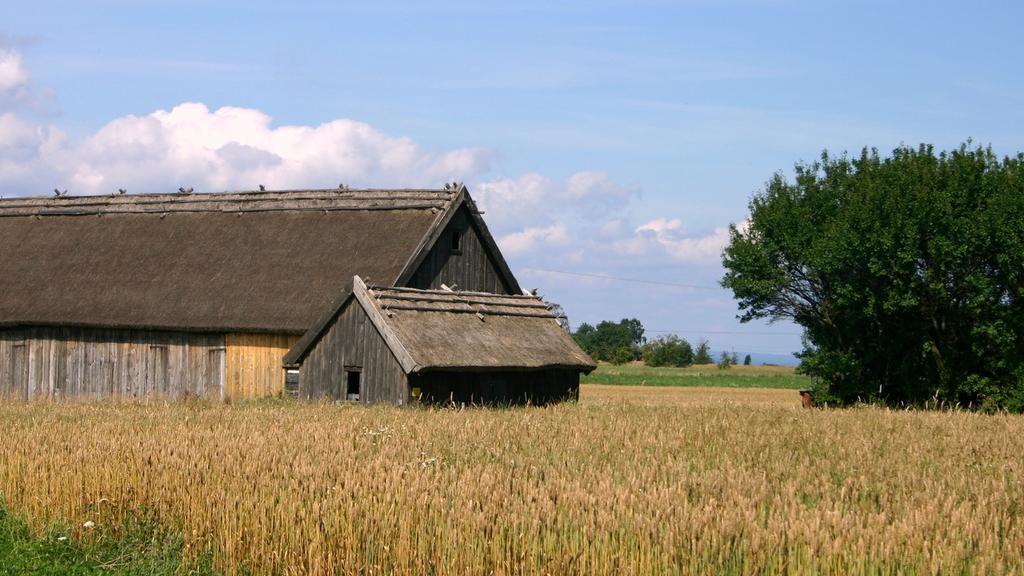Can you describe this image briefly? In the center of the image there is a house. At the bottom of the image there are crops. At the right side of the image there is a tree. At the top of the image there is sky. 